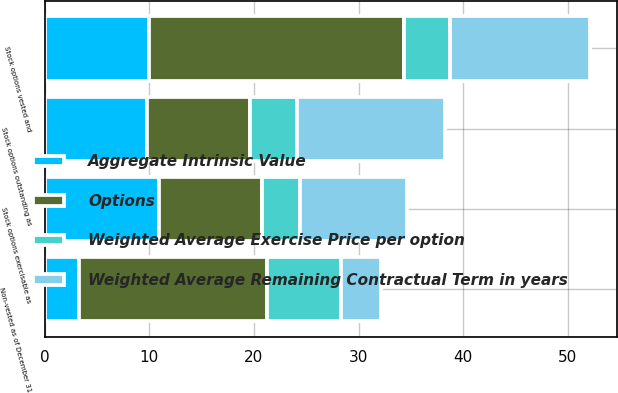Convert chart to OTSL. <chart><loc_0><loc_0><loc_500><loc_500><stacked_bar_chart><ecel><fcel>Stock options outstanding as<fcel>Stock options vested and<fcel>Stock options exercisable as<fcel>Non-vested as of December 31<nl><fcel>Weighted Average Remaining Contractual Term in years<fcel>14.1<fcel>13.4<fcel>10.2<fcel>3.9<nl><fcel>Aggregate Intrinsic Value<fcel>9.76<fcel>9.92<fcel>10.89<fcel>3.29<nl><fcel>Weighted Average Exercise Price per option<fcel>4.5<fcel>4.4<fcel>3.6<fcel>7<nl><fcel>Options<fcel>9.9<fcel>24.4<fcel>9.9<fcel>18<nl></chart> 